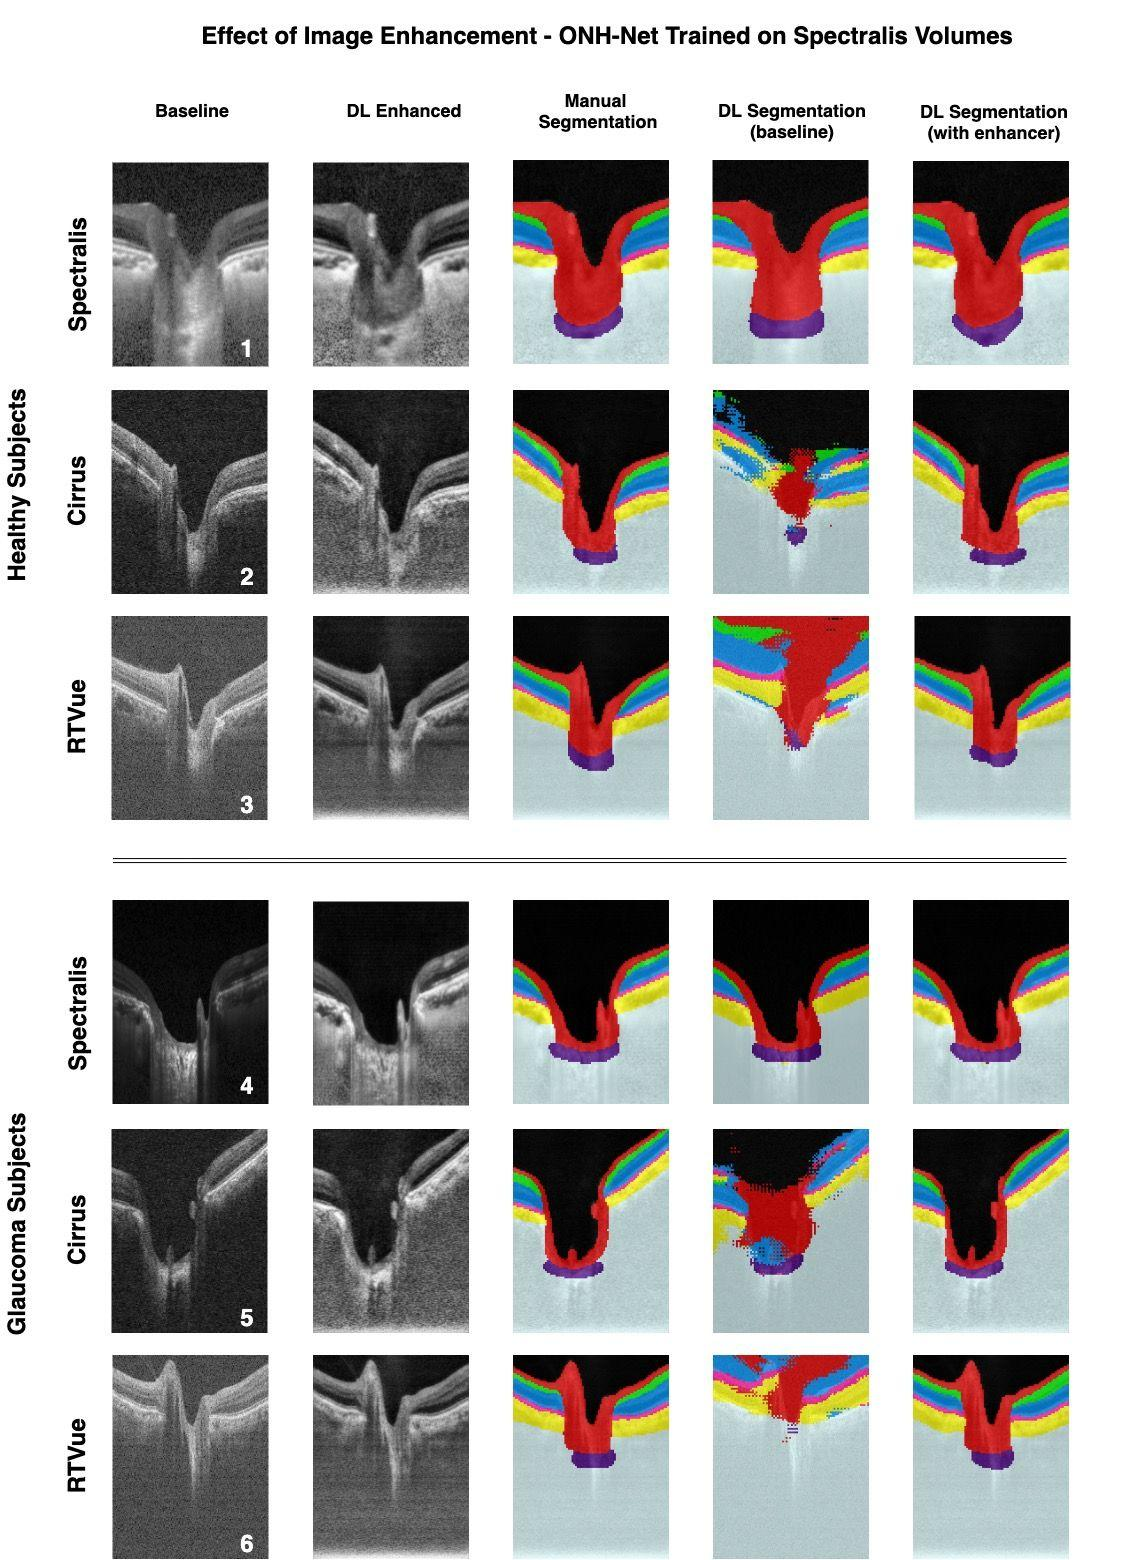What could be the clinical implications of the differences between the DL segmentation on baseline vs. DL segmentation with enhancement for OCT images? The clinical implications of these differences are profound. The DL segmentation on baseline images may miss subtle but clinically significant features due to lower contrast or noise, possibly leading to incorrect assessments. Enhancement brings these features into sharper focus, allowing the DL algorithms to segment the retinal layers with greater accuracy. This improved segmentation with enhancement is crucial for diagnosing and monitoring conditions such as glaucoma, macular degeneration, and diabetic retinopathy, as it can lead to earlier detection and more tailored treatment strategies. 